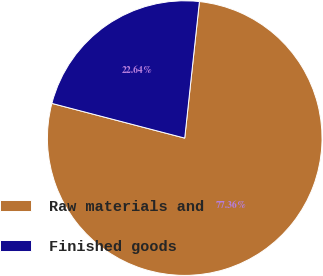<chart> <loc_0><loc_0><loc_500><loc_500><pie_chart><fcel>Raw materials and<fcel>Finished goods<nl><fcel>77.36%<fcel>22.64%<nl></chart> 